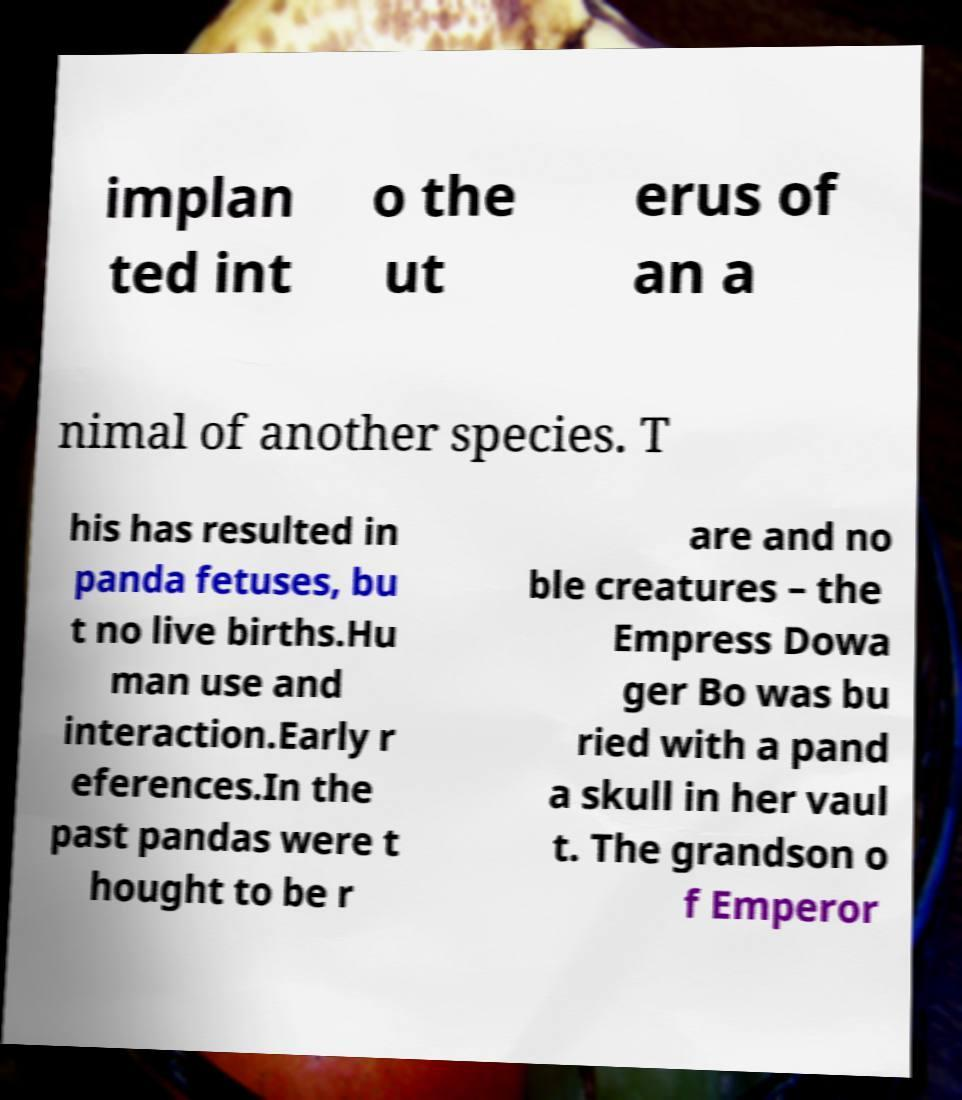I need the written content from this picture converted into text. Can you do that? implan ted int o the ut erus of an a nimal of another species. T his has resulted in panda fetuses, bu t no live births.Hu man use and interaction.Early r eferences.In the past pandas were t hought to be r are and no ble creatures – the Empress Dowa ger Bo was bu ried with a pand a skull in her vaul t. The grandson o f Emperor 